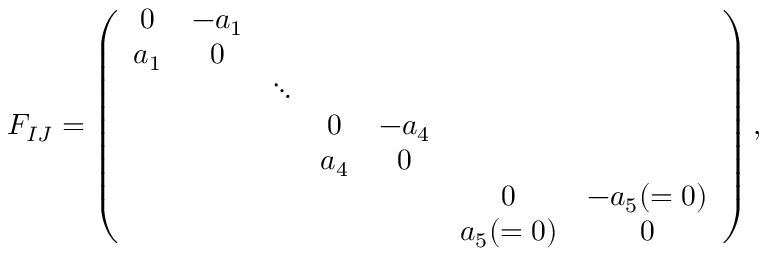<formula> <loc_0><loc_0><loc_500><loc_500>F _ { I J } = \left ( \begin{array} { c c c c c c c } { 0 } & { { - a _ { 1 } } } \\ { { a _ { 1 } } } & { 0 } & { \ddots } & { 0 } & { { - a _ { 4 } } } & { { a _ { 4 } } } & { 0 } & { 0 } & { { - a _ { 5 } ( = 0 ) } } & { { a _ { 5 } ( = 0 ) } } & { 0 } \end{array} \right ) ,</formula> 